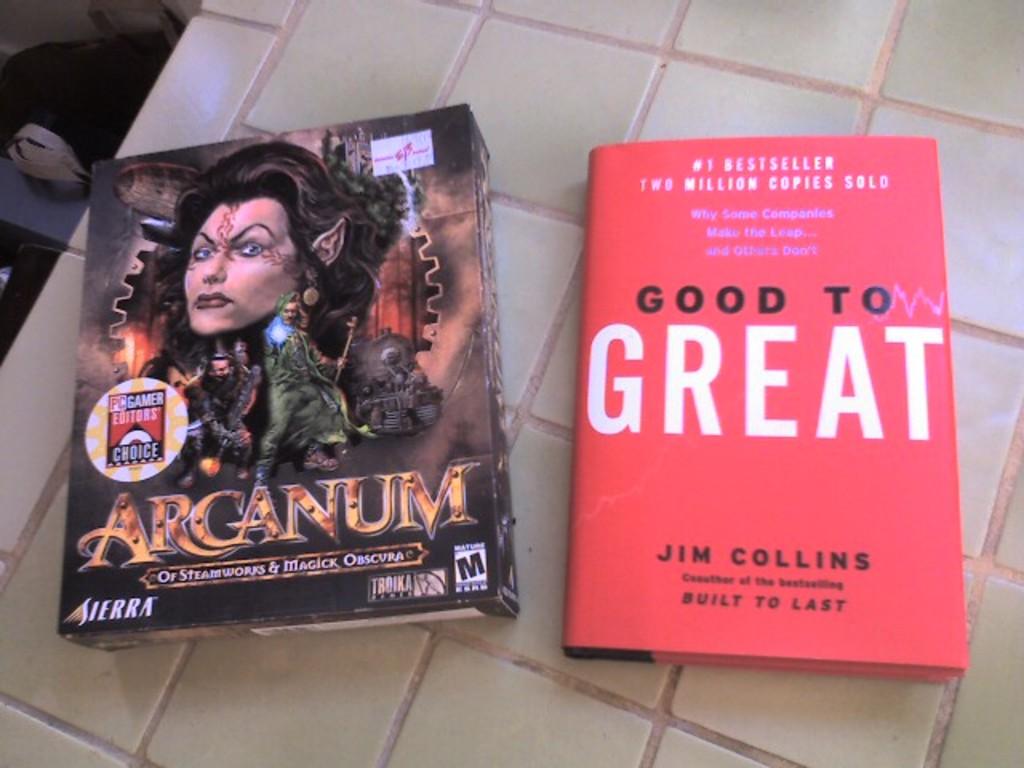"good to great" is written by what author?
Your answer should be compact. Jim collins. What book did jim collins co author?
Keep it short and to the point. Good to great. 